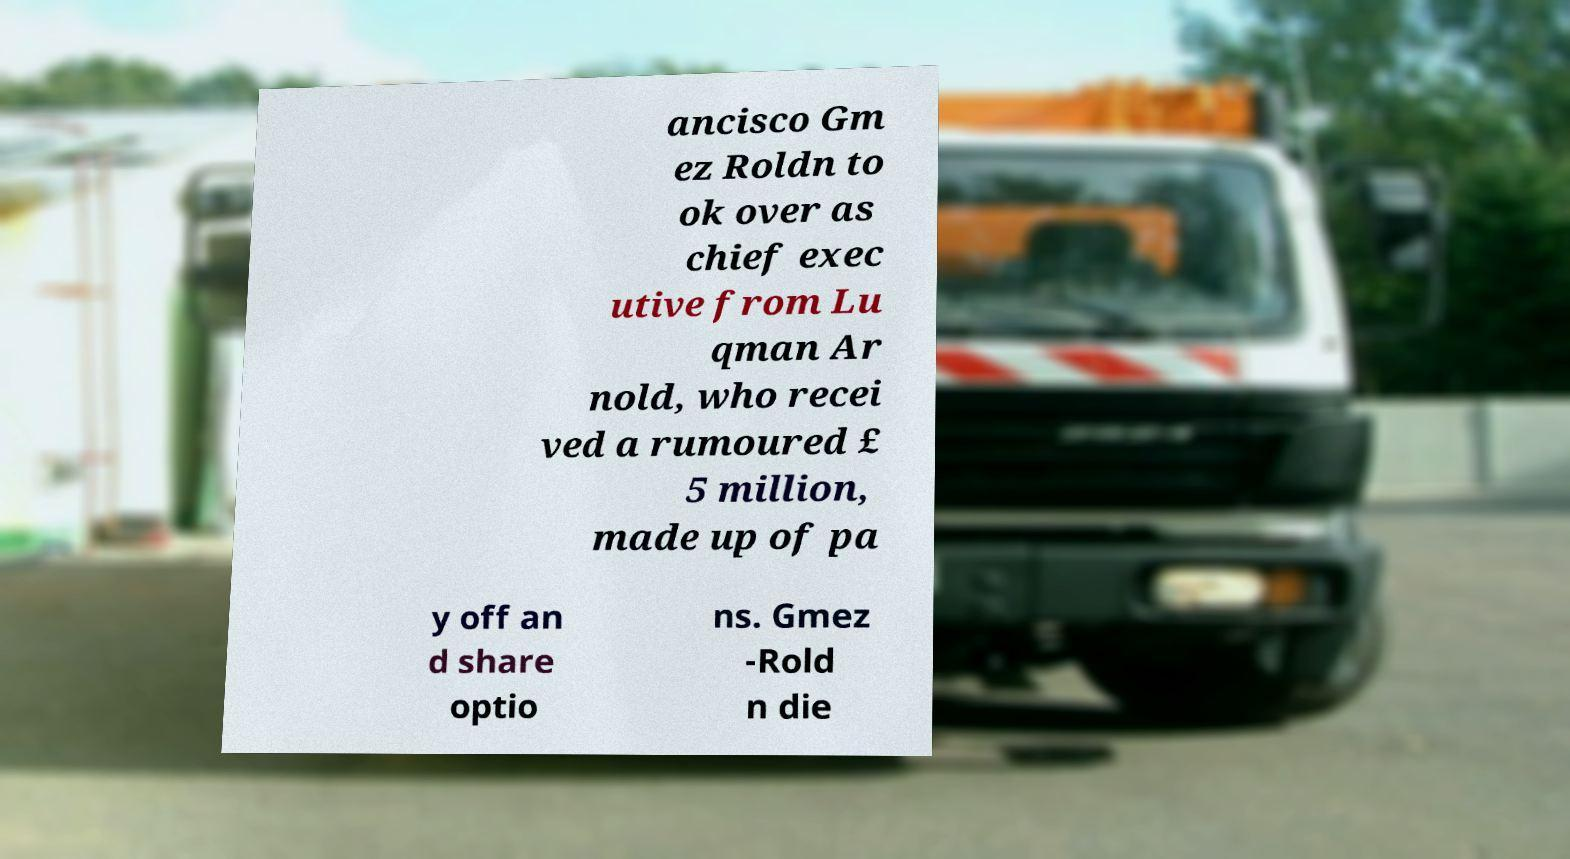Please identify and transcribe the text found in this image. ancisco Gm ez Roldn to ok over as chief exec utive from Lu qman Ar nold, who recei ved a rumoured £ 5 million, made up of pa y off an d share optio ns. Gmez -Rold n die 